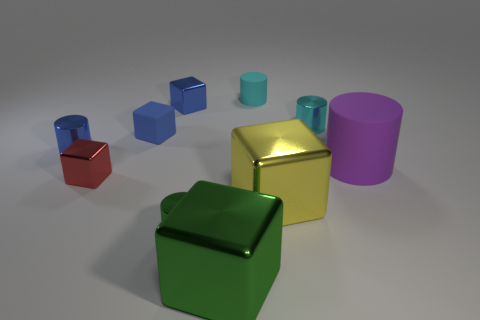There is a metal cylinder in front of the tiny blue thing to the left of the tiny red metallic cube; what color is it?
Keep it short and to the point. Green. Is the number of yellow metal cubes that are behind the large matte cylinder less than the number of metal things in front of the small blue metallic cylinder?
Ensure brevity in your answer.  Yes. Do the purple rubber object and the green shiny cube have the same size?
Provide a succinct answer. Yes. What is the shape of the metal object that is on the right side of the green shiny cylinder and in front of the large yellow metal object?
Offer a terse response. Cube. What number of other objects are the same material as the yellow thing?
Make the answer very short. 6. There is a small cylinder that is in front of the large rubber object; how many yellow metallic cubes are in front of it?
Offer a very short reply. 0. There is a cyan thing that is to the right of the large metal block that is behind the large green thing that is in front of the small green metallic thing; what is its shape?
Ensure brevity in your answer.  Cylinder. How many things are cyan metallic objects or yellow metal blocks?
Keep it short and to the point. 2. The matte object that is the same size as the cyan rubber cylinder is what color?
Your answer should be compact. Blue. There is a purple object; does it have the same shape as the small cyan object on the right side of the large yellow object?
Your answer should be very brief. Yes. 